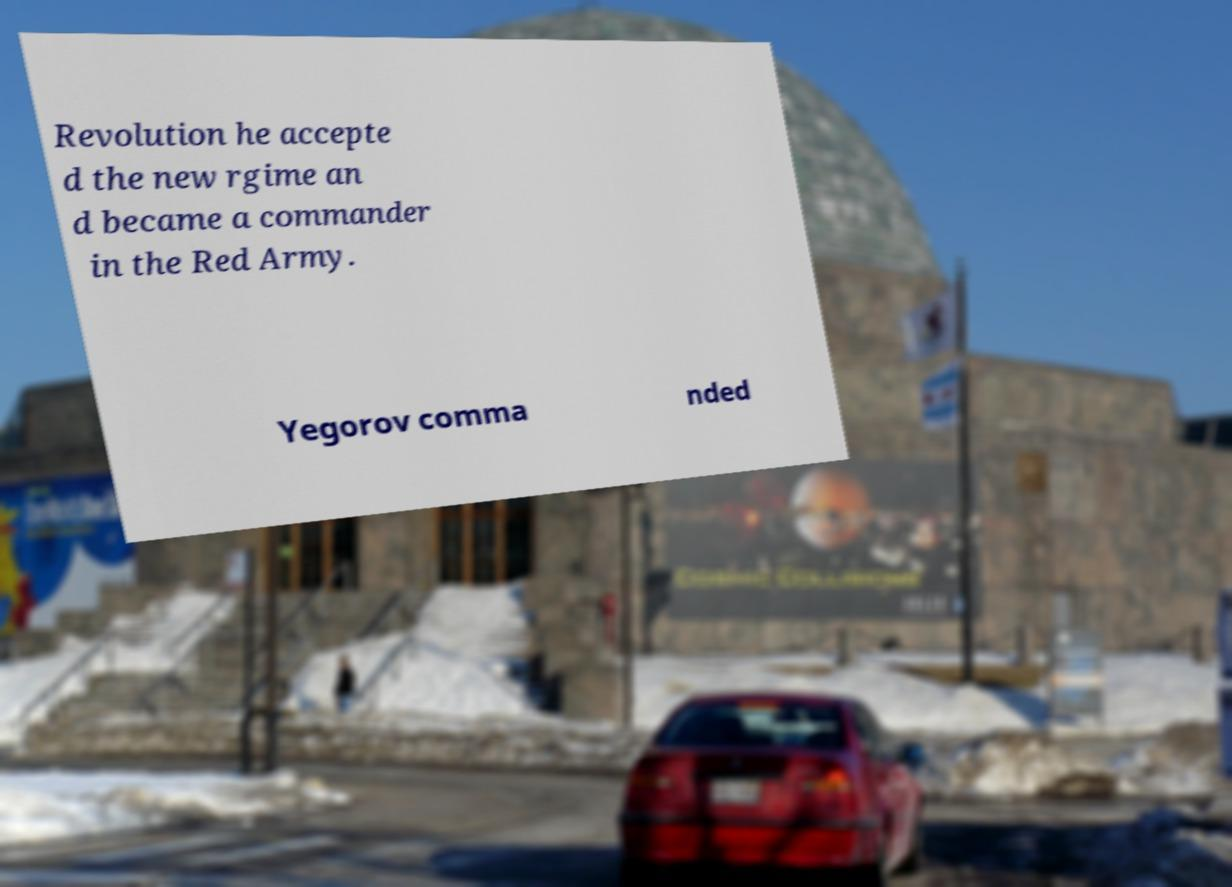I need the written content from this picture converted into text. Can you do that? Revolution he accepte d the new rgime an d became a commander in the Red Army. Yegorov comma nded 